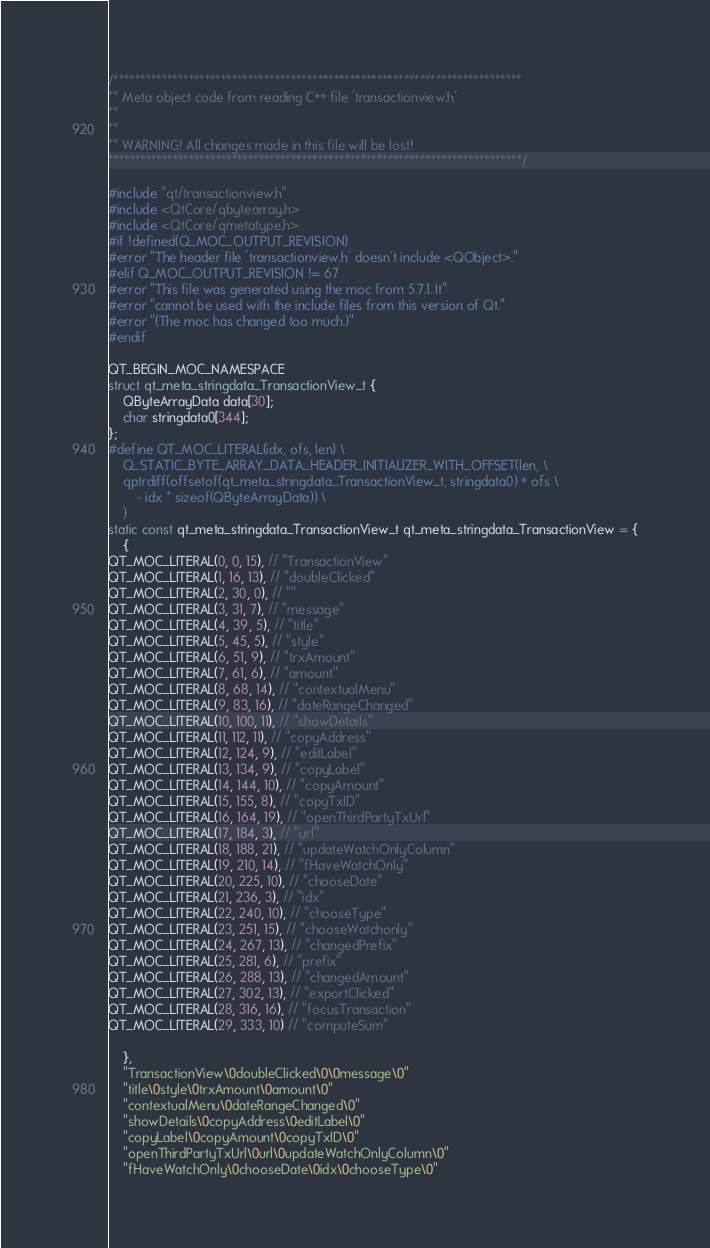<code> <loc_0><loc_0><loc_500><loc_500><_C++_>/****************************************************************************
** Meta object code from reading C++ file 'transactionview.h'
**
**
** WARNING! All changes made in this file will be lost!
*****************************************************************************/

#include "qt/transactionview.h"
#include <QtCore/qbytearray.h>
#include <QtCore/qmetatype.h>
#if !defined(Q_MOC_OUTPUT_REVISION)
#error "The header file 'transactionview.h' doesn't include <QObject>."
#elif Q_MOC_OUTPUT_REVISION != 67
#error "This file was generated using the moc from 5.7.1. It"
#error "cannot be used with the include files from this version of Qt."
#error "(The moc has changed too much.)"
#endif

QT_BEGIN_MOC_NAMESPACE
struct qt_meta_stringdata_TransactionView_t {
    QByteArrayData data[30];
    char stringdata0[344];
};
#define QT_MOC_LITERAL(idx, ofs, len) \
    Q_STATIC_BYTE_ARRAY_DATA_HEADER_INITIALIZER_WITH_OFFSET(len, \
    qptrdiff(offsetof(qt_meta_stringdata_TransactionView_t, stringdata0) + ofs \
        - idx * sizeof(QByteArrayData)) \
    )
static const qt_meta_stringdata_TransactionView_t qt_meta_stringdata_TransactionView = {
    {
QT_MOC_LITERAL(0, 0, 15), // "TransactionView"
QT_MOC_LITERAL(1, 16, 13), // "doubleClicked"
QT_MOC_LITERAL(2, 30, 0), // ""
QT_MOC_LITERAL(3, 31, 7), // "message"
QT_MOC_LITERAL(4, 39, 5), // "title"
QT_MOC_LITERAL(5, 45, 5), // "style"
QT_MOC_LITERAL(6, 51, 9), // "trxAmount"
QT_MOC_LITERAL(7, 61, 6), // "amount"
QT_MOC_LITERAL(8, 68, 14), // "contextualMenu"
QT_MOC_LITERAL(9, 83, 16), // "dateRangeChanged"
QT_MOC_LITERAL(10, 100, 11), // "showDetails"
QT_MOC_LITERAL(11, 112, 11), // "copyAddress"
QT_MOC_LITERAL(12, 124, 9), // "editLabel"
QT_MOC_LITERAL(13, 134, 9), // "copyLabel"
QT_MOC_LITERAL(14, 144, 10), // "copyAmount"
QT_MOC_LITERAL(15, 155, 8), // "copyTxID"
QT_MOC_LITERAL(16, 164, 19), // "openThirdPartyTxUrl"
QT_MOC_LITERAL(17, 184, 3), // "url"
QT_MOC_LITERAL(18, 188, 21), // "updateWatchOnlyColumn"
QT_MOC_LITERAL(19, 210, 14), // "fHaveWatchOnly"
QT_MOC_LITERAL(20, 225, 10), // "chooseDate"
QT_MOC_LITERAL(21, 236, 3), // "idx"
QT_MOC_LITERAL(22, 240, 10), // "chooseType"
QT_MOC_LITERAL(23, 251, 15), // "chooseWatchonly"
QT_MOC_LITERAL(24, 267, 13), // "changedPrefix"
QT_MOC_LITERAL(25, 281, 6), // "prefix"
QT_MOC_LITERAL(26, 288, 13), // "changedAmount"
QT_MOC_LITERAL(27, 302, 13), // "exportClicked"
QT_MOC_LITERAL(28, 316, 16), // "focusTransaction"
QT_MOC_LITERAL(29, 333, 10) // "computeSum"

    },
    "TransactionView\0doubleClicked\0\0message\0"
    "title\0style\0trxAmount\0amount\0"
    "contextualMenu\0dateRangeChanged\0"
    "showDetails\0copyAddress\0editLabel\0"
    "copyLabel\0copyAmount\0copyTxID\0"
    "openThirdPartyTxUrl\0url\0updateWatchOnlyColumn\0"
    "fHaveWatchOnly\0chooseDate\0idx\0chooseType\0"</code> 